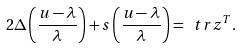Convert formula to latex. <formula><loc_0><loc_0><loc_500><loc_500>2 \Delta \left ( \frac { u - \lambda } { \lambda } \right ) + s \left ( \frac { u - \lambda } { \lambda } \right ) = \ t r z ^ { T } .</formula> 